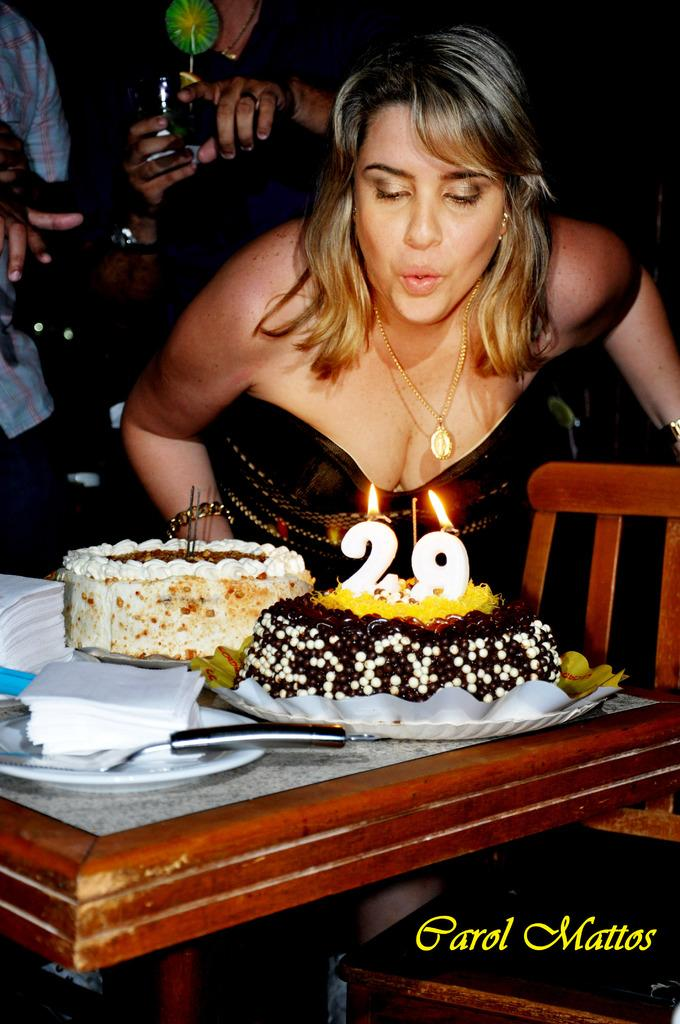Who is present in the image? There is a woman in the image. What is the woman standing near? There is a table in the image. What can be seen on the table? There are cakes, a plate, tissue papers, and a knife on the table. Is there any seating in the image? Yes, there is a chair in the image. Are there any other people visible in the image? Yes, there are two persons in the background of the image. What type of books can be seen on the table in the image? There are no books present on the table in the image. 